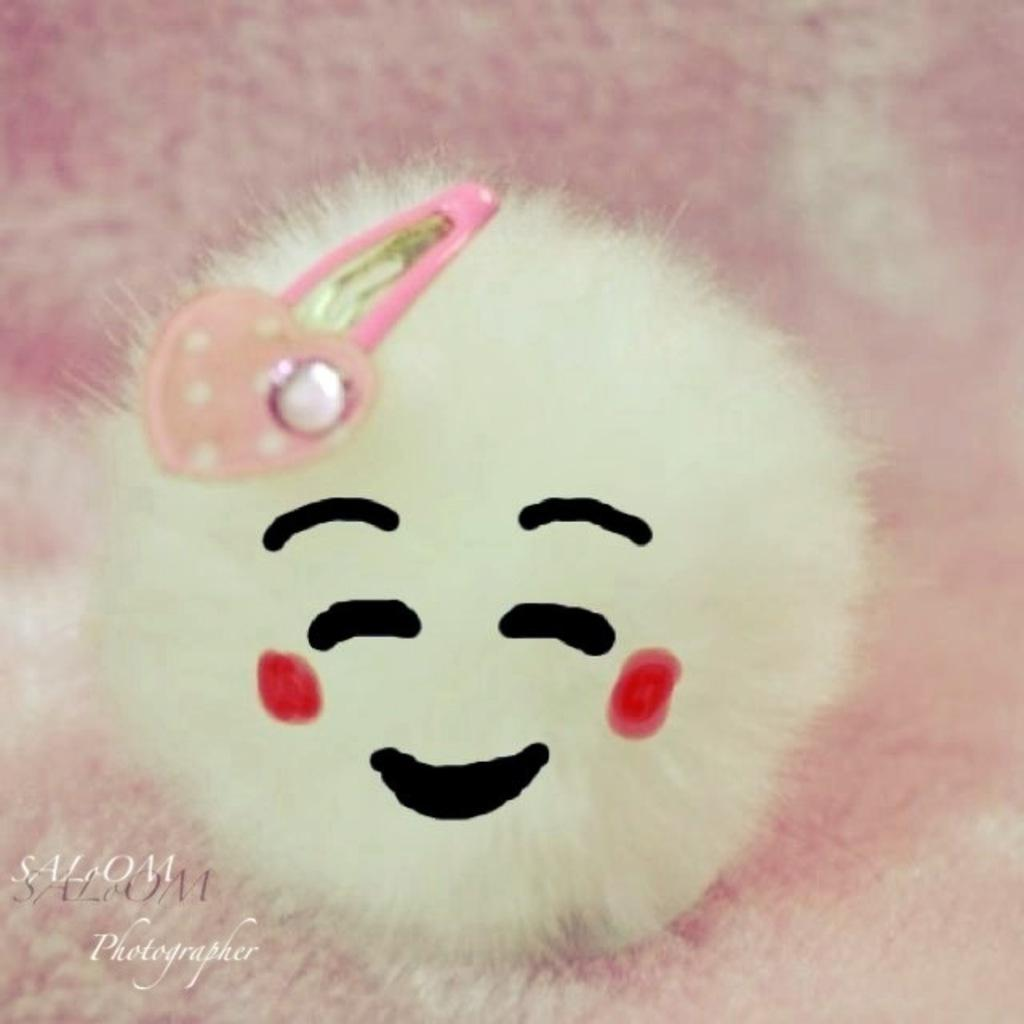What object can be seen in the image? There is a toy in the image. What is the color of the toy? The toy is white in color. Is there any accessory attached to the toy? Yes, there is a hair clip attached to the toy. What is the color of the hair clip? The hair clip is pink in color. What is the color of the surface on which the toy and hair clip are placed? The toy and hair clip are on a pink surface. How does the toy help the bees collect honey in the image? There are no bees or honey mentioned in the image; it only features a toy and a hair clip on a pink surface. 